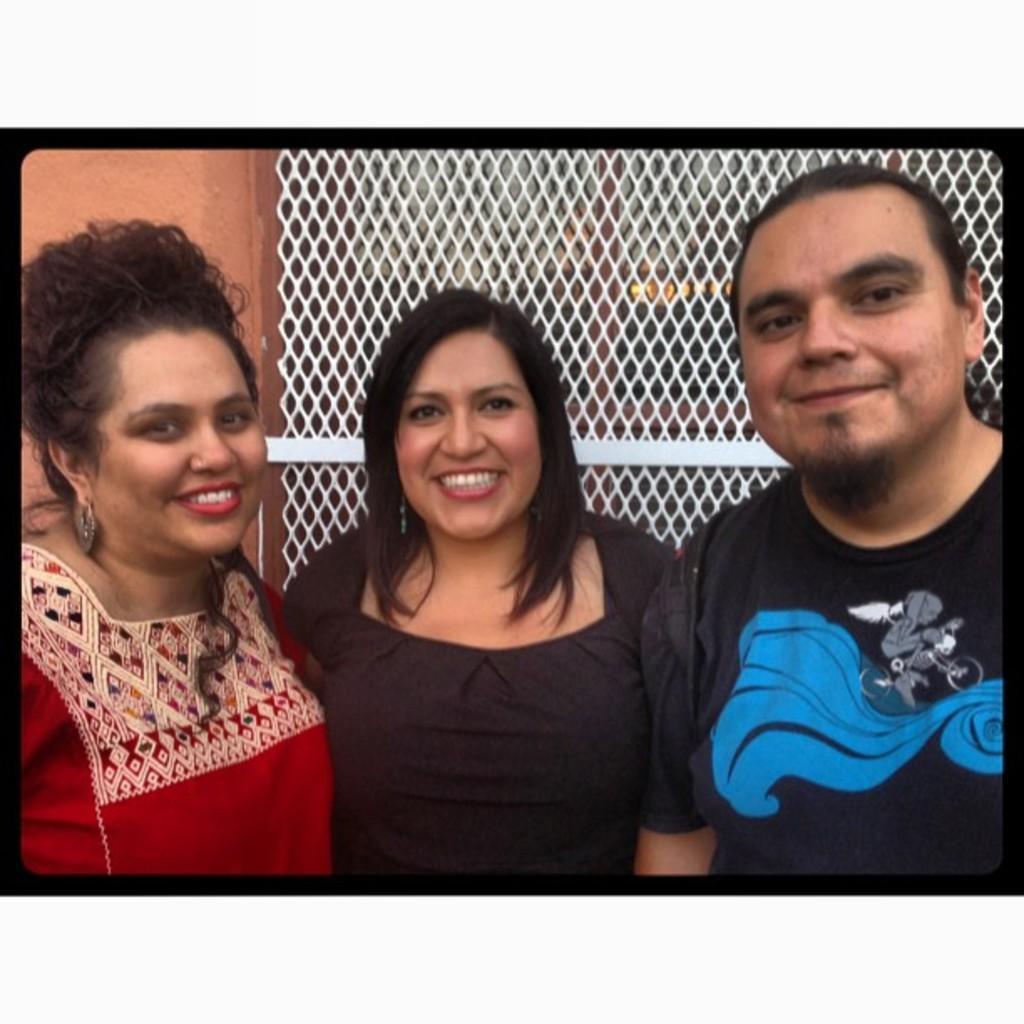Can you describe this image briefly? In this image we can see there are three persons standing near the wall. And we can see the windows attached to the wall. 